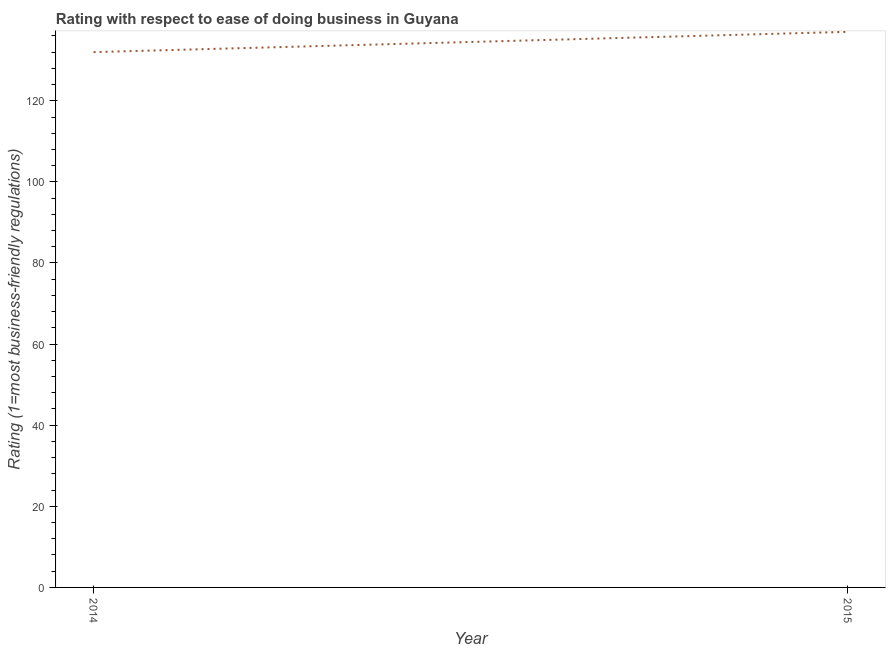What is the ease of doing business index in 2015?
Make the answer very short. 137. Across all years, what is the maximum ease of doing business index?
Your response must be concise. 137. Across all years, what is the minimum ease of doing business index?
Keep it short and to the point. 132. In which year was the ease of doing business index maximum?
Make the answer very short. 2015. In which year was the ease of doing business index minimum?
Your answer should be very brief. 2014. What is the sum of the ease of doing business index?
Give a very brief answer. 269. What is the difference between the ease of doing business index in 2014 and 2015?
Keep it short and to the point. -5. What is the average ease of doing business index per year?
Your answer should be compact. 134.5. What is the median ease of doing business index?
Make the answer very short. 134.5. In how many years, is the ease of doing business index greater than 80 ?
Give a very brief answer. 2. What is the ratio of the ease of doing business index in 2014 to that in 2015?
Your answer should be very brief. 0.96. Is the ease of doing business index in 2014 less than that in 2015?
Offer a very short reply. Yes. How many lines are there?
Ensure brevity in your answer.  1. Does the graph contain any zero values?
Your answer should be very brief. No. Does the graph contain grids?
Ensure brevity in your answer.  No. What is the title of the graph?
Ensure brevity in your answer.  Rating with respect to ease of doing business in Guyana. What is the label or title of the Y-axis?
Provide a short and direct response. Rating (1=most business-friendly regulations). What is the Rating (1=most business-friendly regulations) in 2014?
Keep it short and to the point. 132. What is the Rating (1=most business-friendly regulations) in 2015?
Provide a short and direct response. 137. What is the difference between the Rating (1=most business-friendly regulations) in 2014 and 2015?
Keep it short and to the point. -5. 